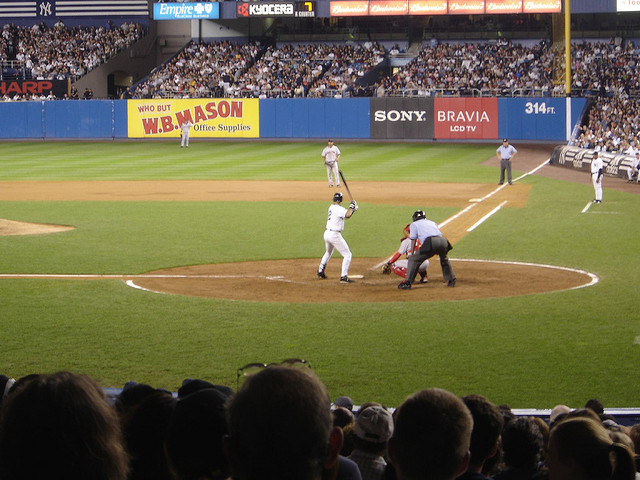Please extract the text content from this image. WHO BUT W.B.MASON Supplies SONY BRAVIA LCD TV 314FT. KYOCERA 7 Empire HARP 